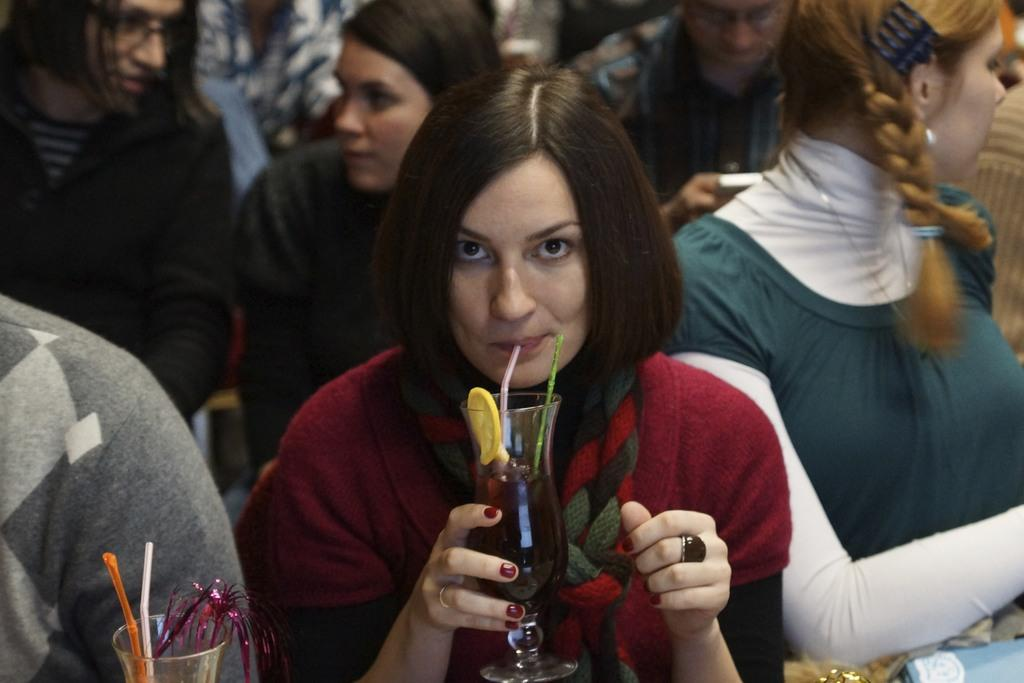Who is the main subject in the image? There is a woman in the image. What is the woman wearing? The woman is wearing a red dress. What is the woman holding in the image? The woman is holding a glass. Can you describe the people behind the woman? Most of the people behind the woman are women. What type of wrench is the woman using to fix the car in the image? There is no car or wrench present in the image; it features a woman in a red dress holding a glass. What kind of breakfast is being served to the people in the image? There is no breakfast or indication of food being served in the image. 